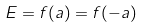<formula> <loc_0><loc_0><loc_500><loc_500>E = f ( a ) = f ( - a )</formula> 